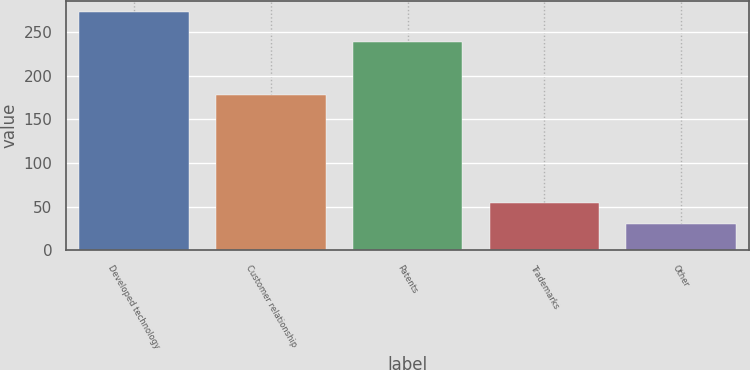Convert chart. <chart><loc_0><loc_0><loc_500><loc_500><bar_chart><fcel>Developed technology<fcel>Customer relationship<fcel>Patents<fcel>Trademarks<fcel>Other<nl><fcel>272.4<fcel>177.9<fcel>239<fcel>54.51<fcel>30.3<nl></chart> 